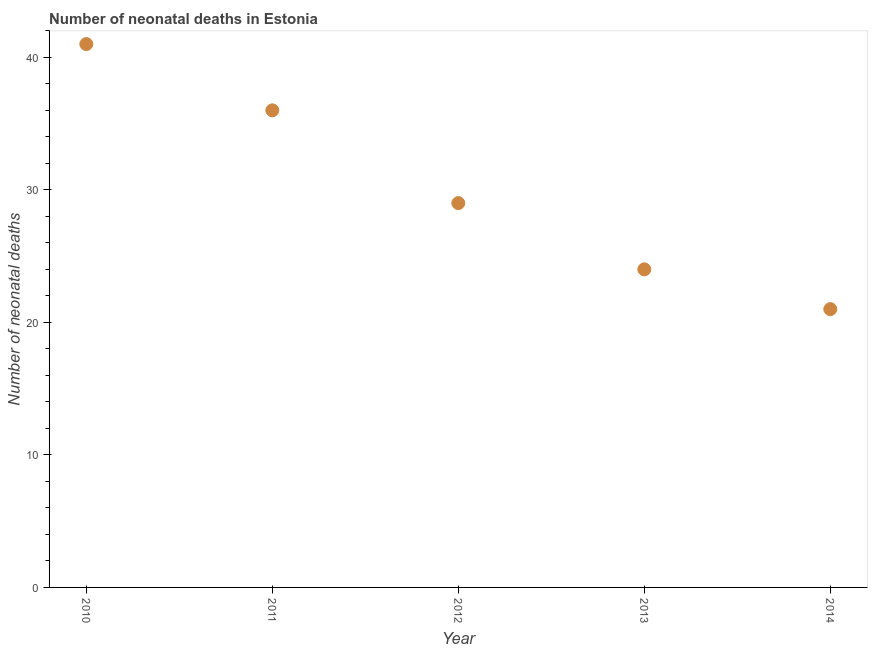What is the number of neonatal deaths in 2011?
Keep it short and to the point. 36. Across all years, what is the maximum number of neonatal deaths?
Give a very brief answer. 41. Across all years, what is the minimum number of neonatal deaths?
Your answer should be compact. 21. In which year was the number of neonatal deaths maximum?
Provide a succinct answer. 2010. What is the sum of the number of neonatal deaths?
Keep it short and to the point. 151. What is the difference between the number of neonatal deaths in 2013 and 2014?
Ensure brevity in your answer.  3. What is the average number of neonatal deaths per year?
Offer a very short reply. 30.2. What is the ratio of the number of neonatal deaths in 2013 to that in 2014?
Ensure brevity in your answer.  1.14. What is the difference between the highest and the second highest number of neonatal deaths?
Provide a succinct answer. 5. Is the sum of the number of neonatal deaths in 2010 and 2014 greater than the maximum number of neonatal deaths across all years?
Keep it short and to the point. Yes. What is the difference between the highest and the lowest number of neonatal deaths?
Keep it short and to the point. 20. How many dotlines are there?
Ensure brevity in your answer.  1. How many years are there in the graph?
Ensure brevity in your answer.  5. Does the graph contain grids?
Your answer should be compact. No. What is the title of the graph?
Make the answer very short. Number of neonatal deaths in Estonia. What is the label or title of the X-axis?
Provide a short and direct response. Year. What is the label or title of the Y-axis?
Your answer should be very brief. Number of neonatal deaths. What is the Number of neonatal deaths in 2010?
Your answer should be compact. 41. What is the Number of neonatal deaths in 2012?
Make the answer very short. 29. What is the Number of neonatal deaths in 2013?
Provide a succinct answer. 24. What is the difference between the Number of neonatal deaths in 2010 and 2014?
Offer a very short reply. 20. What is the difference between the Number of neonatal deaths in 2011 and 2012?
Provide a succinct answer. 7. What is the difference between the Number of neonatal deaths in 2011 and 2014?
Your answer should be very brief. 15. What is the difference between the Number of neonatal deaths in 2013 and 2014?
Offer a very short reply. 3. What is the ratio of the Number of neonatal deaths in 2010 to that in 2011?
Offer a very short reply. 1.14. What is the ratio of the Number of neonatal deaths in 2010 to that in 2012?
Ensure brevity in your answer.  1.41. What is the ratio of the Number of neonatal deaths in 2010 to that in 2013?
Ensure brevity in your answer.  1.71. What is the ratio of the Number of neonatal deaths in 2010 to that in 2014?
Ensure brevity in your answer.  1.95. What is the ratio of the Number of neonatal deaths in 2011 to that in 2012?
Your answer should be compact. 1.24. What is the ratio of the Number of neonatal deaths in 2011 to that in 2014?
Give a very brief answer. 1.71. What is the ratio of the Number of neonatal deaths in 2012 to that in 2013?
Give a very brief answer. 1.21. What is the ratio of the Number of neonatal deaths in 2012 to that in 2014?
Keep it short and to the point. 1.38. What is the ratio of the Number of neonatal deaths in 2013 to that in 2014?
Offer a very short reply. 1.14. 